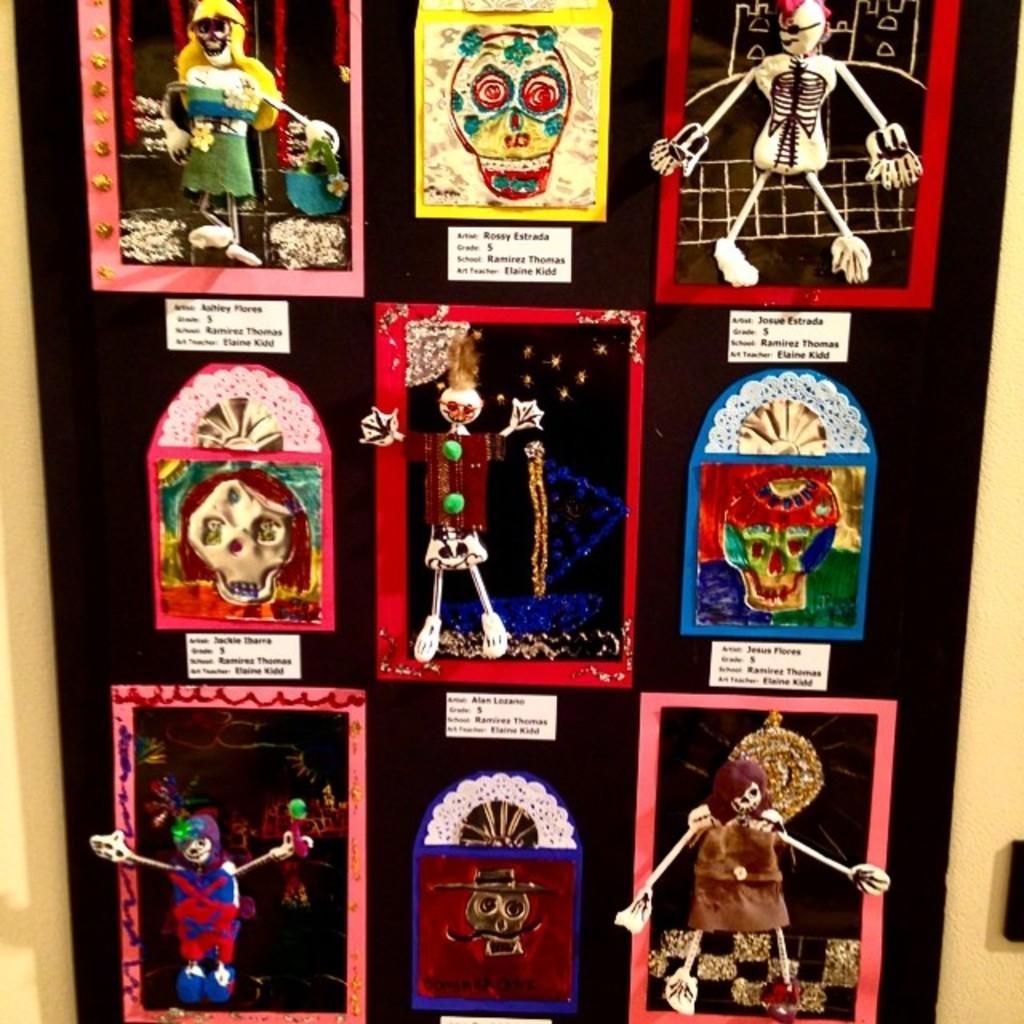Could you give a brief overview of what you see in this image? In this image we can see the dolls and some pictures on the surface. We can also see some text. 